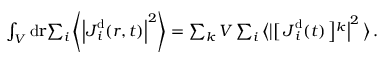<formula> <loc_0><loc_0><loc_500><loc_500>\begin{array} { r l } & { \int _ { V } d { r } { \sum _ { i } \left \langle \left | { J } _ { i } ^ { d } ( { r } , t ) \right | ^ { 2 } \right \rangle } = \sum _ { k } V \sum _ { i } \left \langle \left | \right [ J _ { i } ^ { d } ( t ) \left ] ^ { k } \right | ^ { 2 } \right \rangle \, . } \end{array}</formula> 